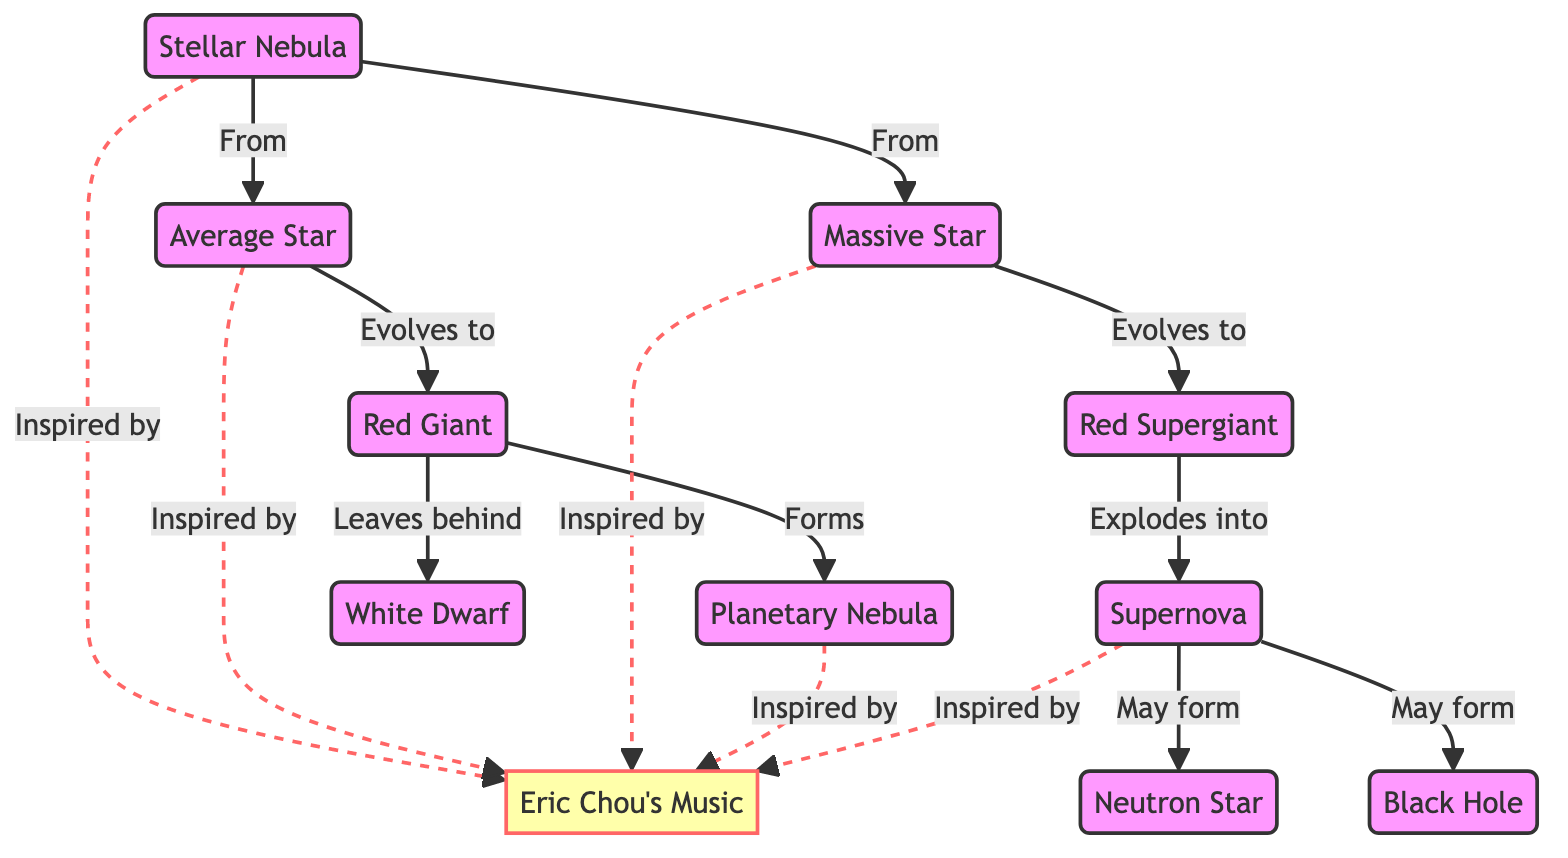What is the initial state of a star according to the diagram? The diagram starts with a "Stellar Nebula," which is the initial state from which stars are formed.
Answer: Stellar Nebula How many final states are indicated for the evolution of massive stars? From the diagram, a massive star can evolve into either a neutron star or a black hole after a supernova, which gives us two potential final states for massive stars.
Answer: 2 What type of star evolves into a red giant? The diagram shows that an "Average Star" evolves into a "Red Giant," indicating that this is the specific type of star that goes through this stage.
Answer: Average Star What does a red giant leave behind after it forms a planetary nebula? The diagram indicates that a red giant leaves behind a "White Dwarf" after forming a planetary nebula, signifying the remnants of a star at this stage.
Answer: White Dwarf Which phase is indicated as an inspiration for Eric Chou's music in multiple places? "Stellar Nebula," "Average Star," "Massive Star," "Planetary Nebula," and "Supernova" are all connected to Eric Chou's music as inspirations, but specific links everywhere highlight each phase's connection.
Answer: Stellar Nebula, Average Star, Massive Star, Planetary Nebula, Supernova What transition follows the supernova stage for a massive star? Following the supernova stage, the diagram shows two possible outcomes: a neutron star or a black hole, which are the transitions for a massive star post-explosion.
Answer: Neutron Star or Black Hole How does a red supergiant differ from a red giant in the diagram? The red supergiant evolves from a massive star, while a red giant evolves from an average star, highlighting their differences depending on the mass of the original star.
Answer: Red Giant and Red Supergiant What kind of music is said to inspire the lifecycle of stars throughout the diagram? The diagram consistently references Eric Chou's music as an inspiring thematic element joined at multiple stages in the lifecycle of stars.
Answer: Eric Chou's Music 